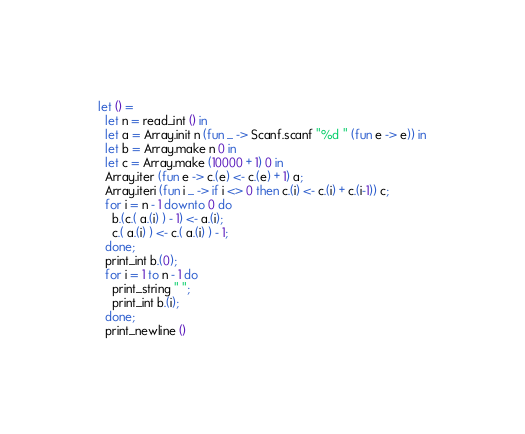Convert code to text. <code><loc_0><loc_0><loc_500><loc_500><_OCaml_>let () =
  let n = read_int () in
  let a = Array.init n (fun _ -> Scanf.scanf "%d " (fun e -> e)) in
  let b = Array.make n 0 in
  let c = Array.make (10000 + 1) 0 in
  Array.iter (fun e -> c.(e) <- c.(e) + 1) a;
  Array.iteri (fun i _ -> if i <> 0 then c.(i) <- c.(i) + c.(i-1)) c;
  for i = n - 1 downto 0 do
    b.(c.( a.(i) ) - 1) <- a.(i);
    c.( a.(i) ) <- c.( a.(i) ) - 1;
  done;
  print_int b.(0);
  for i = 1 to n - 1 do
    print_string " ";
    print_int b.(i);
  done;
  print_newline ()</code> 